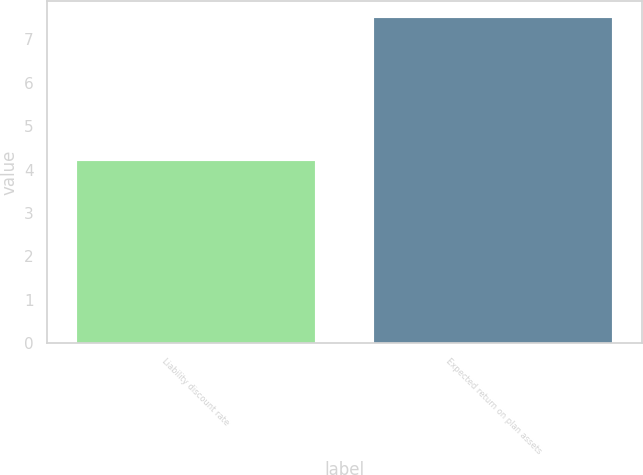Convert chart to OTSL. <chart><loc_0><loc_0><loc_500><loc_500><bar_chart><fcel>Liability discount rate<fcel>Expected return on plan assets<nl><fcel>4.2<fcel>7.5<nl></chart> 